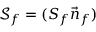Convert formula to latex. <formula><loc_0><loc_0><loc_500><loc_500>\mathcal { S } _ { f } = ( { S _ { f } } \vec { n } _ { f } )</formula> 